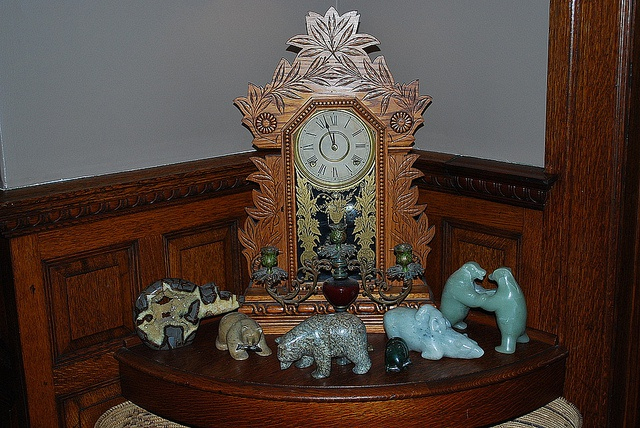Describe the objects in this image and their specific colors. I can see clock in gray, darkgray, black, and lightgray tones, bear in gray, black, and darkgray tones, and bear in gray and black tones in this image. 